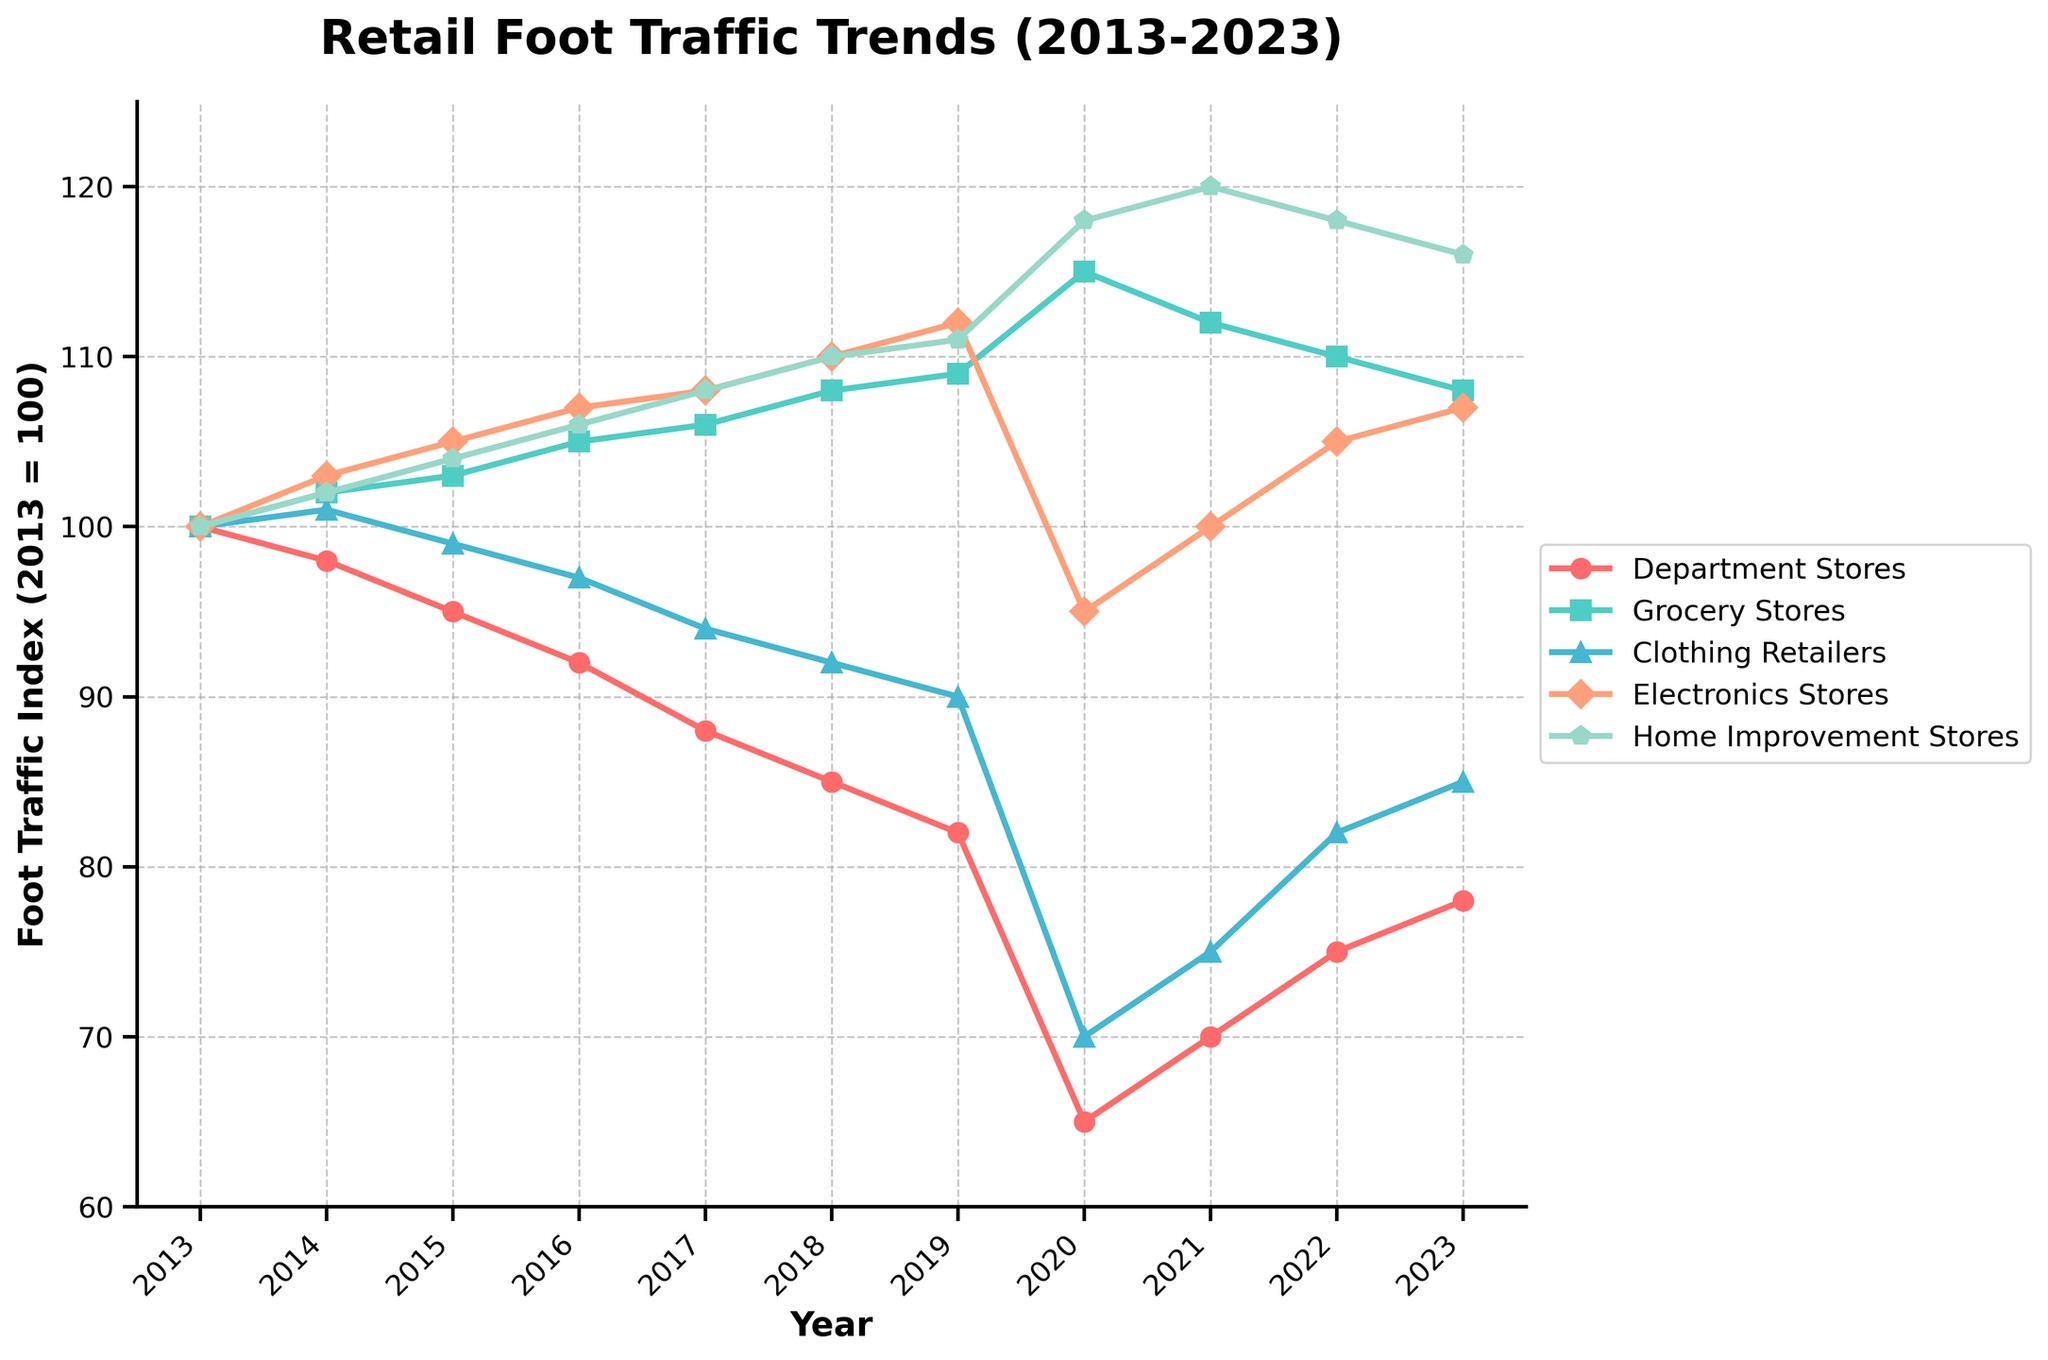What year did Grocery Stores have the highest foot traffic index? By checking the Grocery Stores line in the chart, observe the peak value. 115 in 2020 is the highest point.
Answer: 2020 Which store type saw the most significant drop in foot traffic in 2020? Compare the foot traffic index for all store types from 2019 to 2020. Department Stores dropped from 82 to 65, which is the most significant drop.
Answer: Department Stores Between 2017 and 2023, which store type experienced the greatest percentage increase in foot traffic? Calculate the percentage increase for each store type between 2017 and 2023 (percentage increase = [(value in 2023 - value in 2017) / value in 2017] * 100). Department Stores: [(78-88)/88]*100 = -11.36%, Grocery Stores: [(108-106)/106]*100 = 1.89%, Clothing Retailers: [(85-94)/94]*100 = -9.57%, Electronics Stores: [(107-108)/108]*100 = -0.93%, Home Improvement Stores: [(116-108)/108]*100 = 7.41%. The Home Improvement Stores have the greatest percentage increase.
Answer: Home Improvement Stores In which years did the Electronics Stores have equal or higher foot traffic compared to Home Improvement Stores? By comparing each year, only in 2017 and 2018 did both Electronics Stores and Home Improvement Stores have equal foot traffic, with Electronics Stores exceeding in 2019.
Answer: 2017, 2018, 2019 Identify the year in which Clothing Retailers and Department Stores’ foot traffic indices were closest to each other. Find the absolute difference between the indices for Clothing Retailers and Department Stores over the years. The smallest difference occurs in 2022 with indices of 82 and 75 respectively, resulting in 7.
Answer: 2022 Between Home Improvement Stores and Grocery Stores, which had a higher average foot traffic index over the decade? Calculate the average for both stores from 2013 to 2023: Home Improvement Stores' average = (100+102+104+106+108+110+111+118+120+118+116)/11 = 109.73, Grocery Stores' average = (100+102+103+105+106+108+109+115+112+110+108)/11 = 108.63. Home Improvement Stores have a higher average.
Answer: Home Improvement Stores Which store type shows the most consistent trend in foot traffic index over the decade? Consistency can be interpreted by the trendline smoothness and fewer fluctuations. Grocery Stores exhibit the most consistent upward trend every year.
Answer: Grocery Stores Calculate the total difference in foot traffic index for Electronics Stores between 2013 and 2023. Subtract the index in 2013 from that in 2023. The difference is 107 - 100 = 7.
Answer: 7 How did the foot traffic trend for Department Stores compare to the overall trend for the other types of stores over the decade? Department Stores show a steady decline from 100 to 78, while other store types show varying trends but generally increased, especially during the pandemic in 2020.
Answer: Department Stores declined, others increased What trend do Home Improvement Stores exhibit during the pandemic (2020)? The index shows a significant rise during the pandemic years (2020-2021), from 118 in 2020 to 120 in 2021.
Answer: Significant rise 